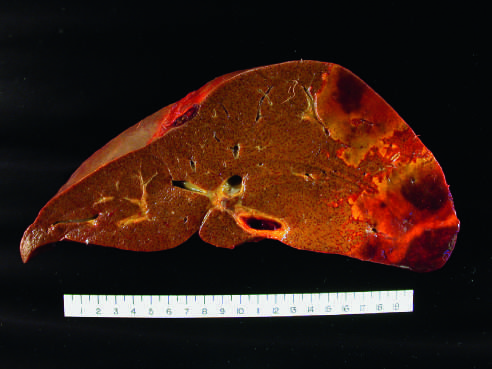what is the distal hepatic tissue pale with?
Answer the question using a single word or phrase. A hemorrhagic margin 